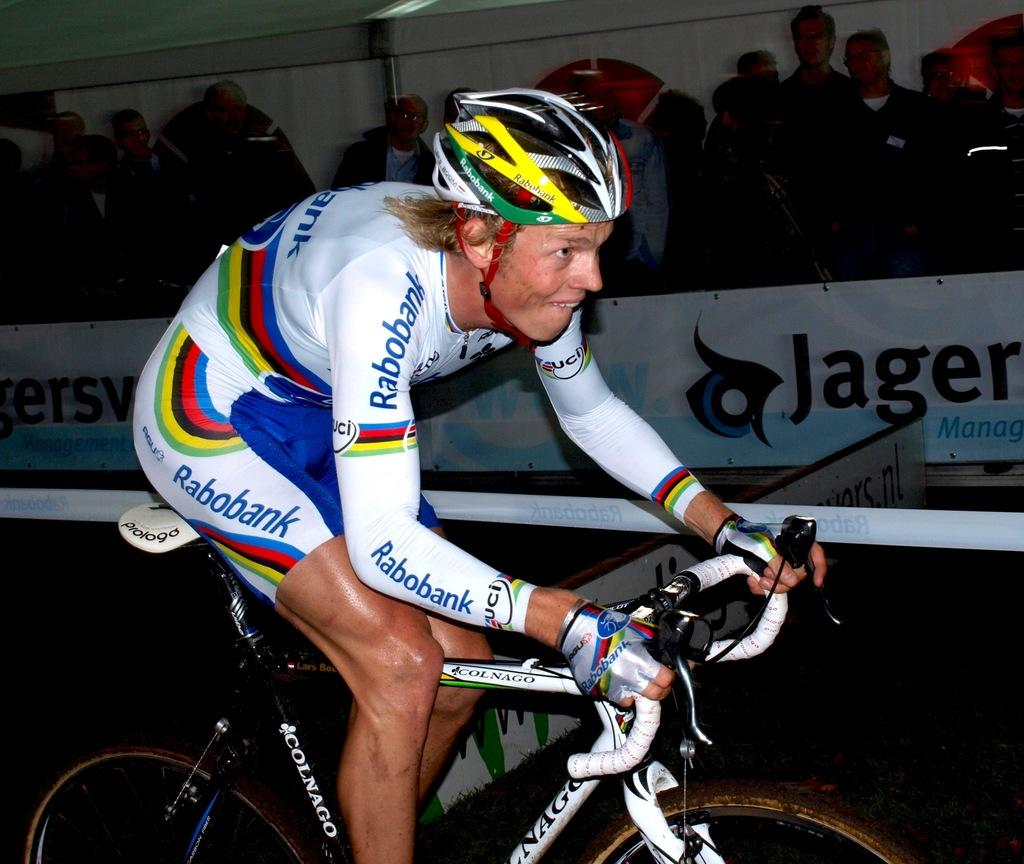What is the main subject of the image? The main subject of the image is a person riding a bicycle. What is the person wearing in the image? The person is wearing a white t-shirt. Can you describe the background of the image? There is a group of people standing at the back, and there is a hoarding at the bottom of the image. What type of account does the government have with the person riding the bicycle in the image? There is no mention of an account or the government in the image, as it only features a person riding a bicycle and a group of people standing at the back. --- Facts: 1. There is a car in the image. 2. The car is red. 3. The car has four wheels. 4. There is a road in the image. 5. The road is paved. Absurd Topics: bird, ocean, mountain Conversation: What is the main subject of the image? The main subject of the image is a car. What color is the car in the image? The car is red. How many wheels does the car have? The car has four wheels. What type of surface can be seen in the image? There is a road in the image, and it is paved. Reasoning: Let's think step by step in order to produce the conversation. We start by identifying the main subject of the image, which is the car. Then, we describe the car's color, which is red. Next, we mention the number of wheels the car has, which is four. Finally, we expand the conversation to include the road in the image, noting that it is paved. Absurd Question/Answer: Can you see any birds flying over the ocean in the image? There is no ocean or birds present in the image; it only features a red car and a paved road. --- Facts: 1. There is a group of people sitting on the grass in the image. 2. The people are wearing casual clothes. 3. There is a picnic basket in the image. 4. There are trees in the background. 5. The sky is visible in the image. Absurd Topics: snow, volcano, spaceship Conversation: What is the main subject of the image? The main subject of the image is a group of people sitting on the grass. What are the people wearing in the image? The people are wearing casual clothes. What can be seen in the image besides the people? There is a picnic basket in the image. What type of vegetation is visible in the background? There are trees in the background. What is visible at the top of the image? The sky is visible in the image. Reasoning: Let's think step by step in order to 